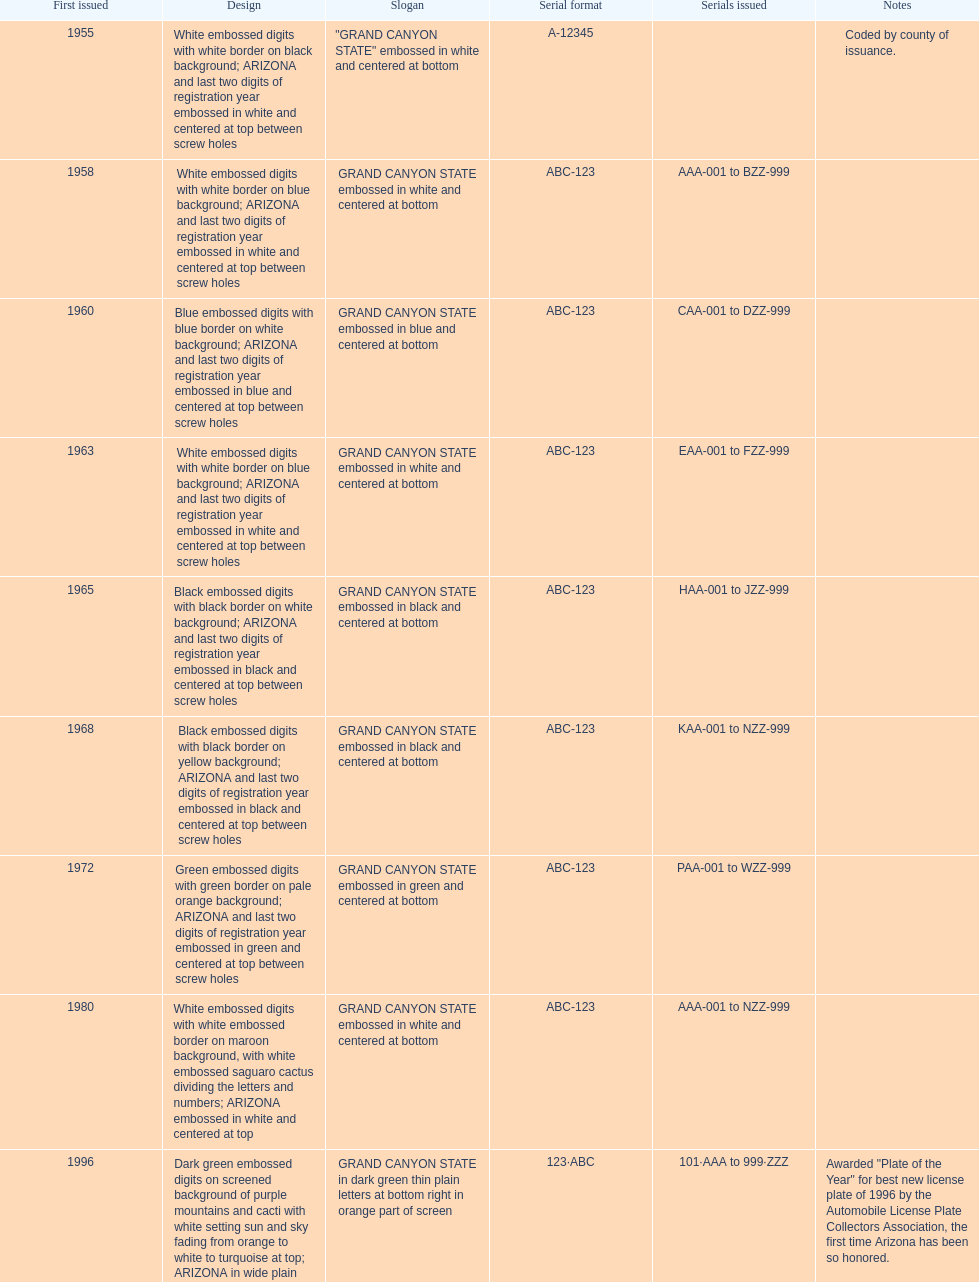In which year was the license plate with the most alphanumeric digits released? 2008. 